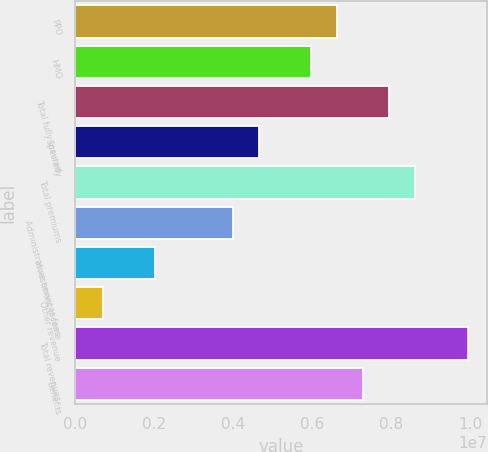<chart> <loc_0><loc_0><loc_500><loc_500><bar_chart><fcel>PPO<fcel>HMO<fcel>Total fully-insured<fcel>Specialty<fcel>Total premiums<fcel>Administrative services fees<fcel>Investment income<fcel>Other revenue<fcel>Total revenues<fcel>Benefits<nl><fcel>6.63542e+06<fcel>5.9754e+06<fcel>7.95546e+06<fcel>4.65536e+06<fcel>8.61548e+06<fcel>3.99534e+06<fcel>2.01529e+06<fcel>695248<fcel>9.93551e+06<fcel>7.29544e+06<nl></chart> 